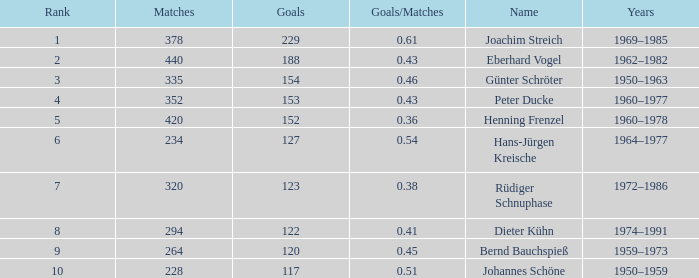What years have goals less than 229, and 440 as matches? 1962–1982. 